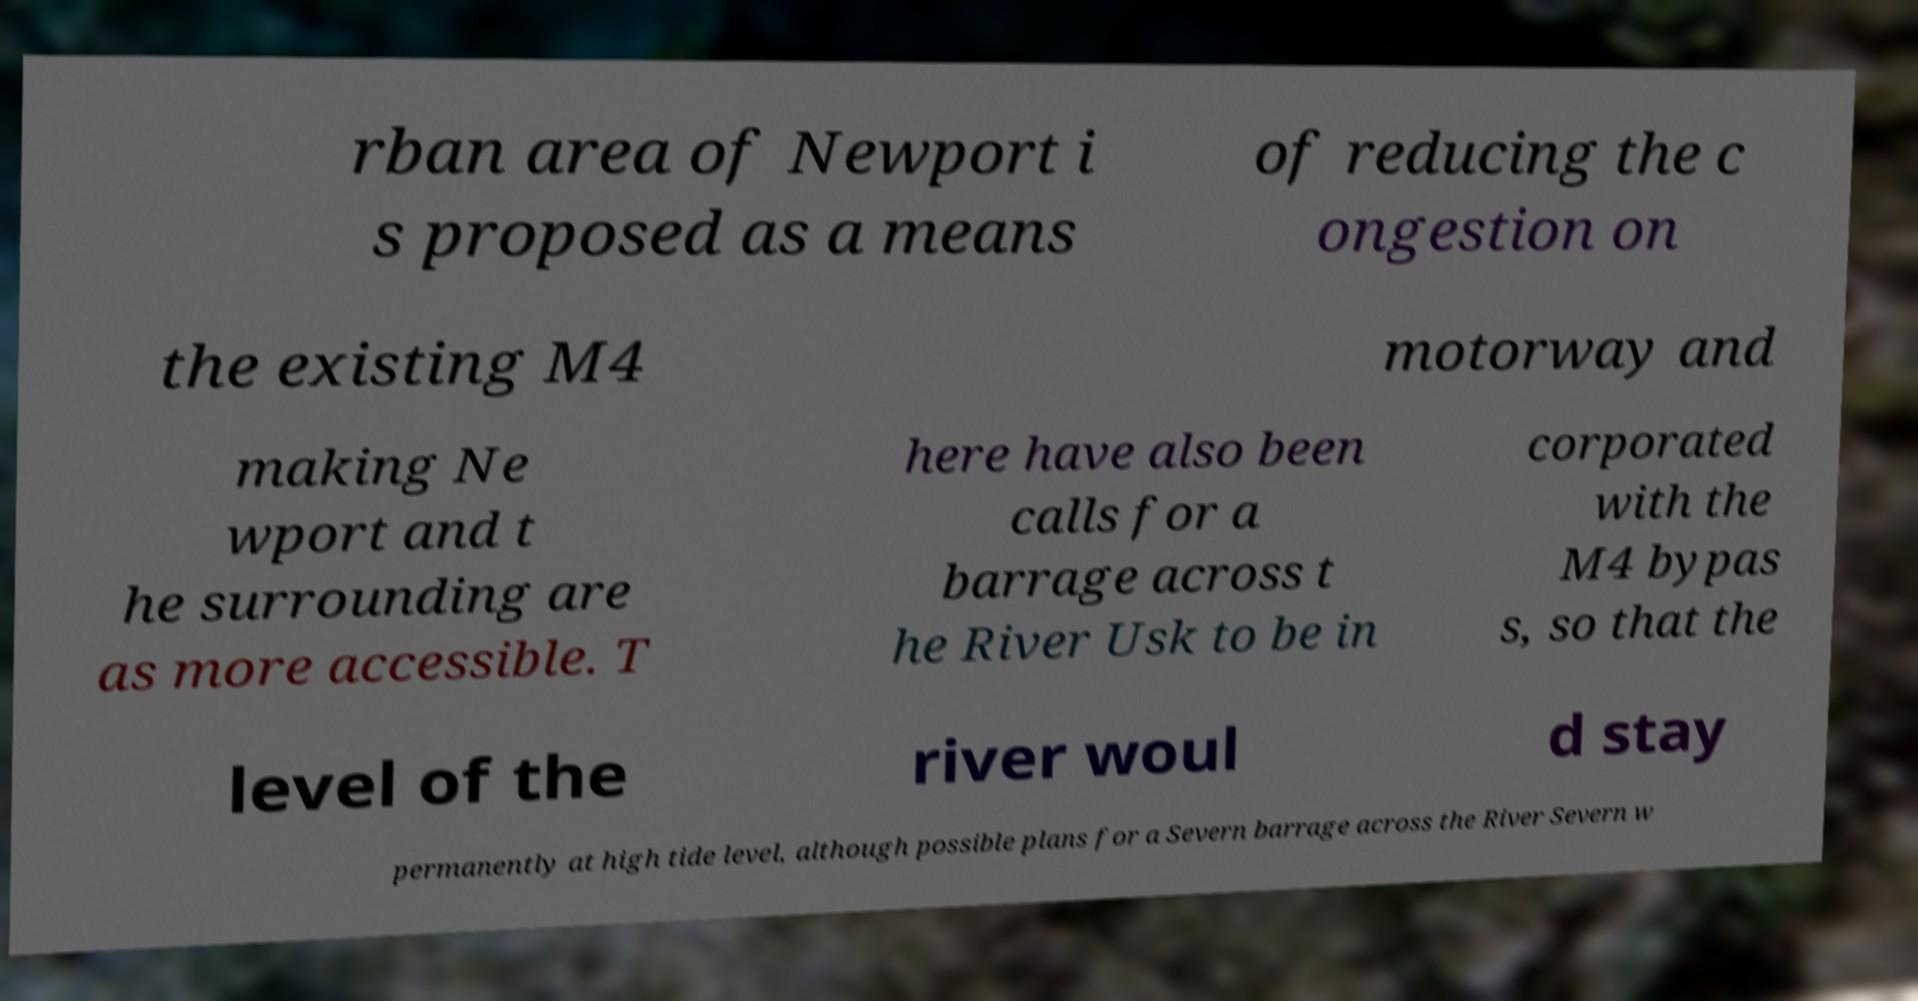There's text embedded in this image that I need extracted. Can you transcribe it verbatim? rban area of Newport i s proposed as a means of reducing the c ongestion on the existing M4 motorway and making Ne wport and t he surrounding are as more accessible. T here have also been calls for a barrage across t he River Usk to be in corporated with the M4 bypas s, so that the level of the river woul d stay permanently at high tide level, although possible plans for a Severn barrage across the River Severn w 